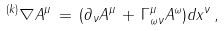Convert formula to latex. <formula><loc_0><loc_0><loc_500><loc_500>^ { ( k ) } \nabla A ^ { \mu } \, = \, ( \partial _ { \nu } A ^ { \mu } \, + \, \Gamma ^ { \mu } _ { \omega \nu } A ^ { \omega } ) d x ^ { \nu } \, ,</formula> 